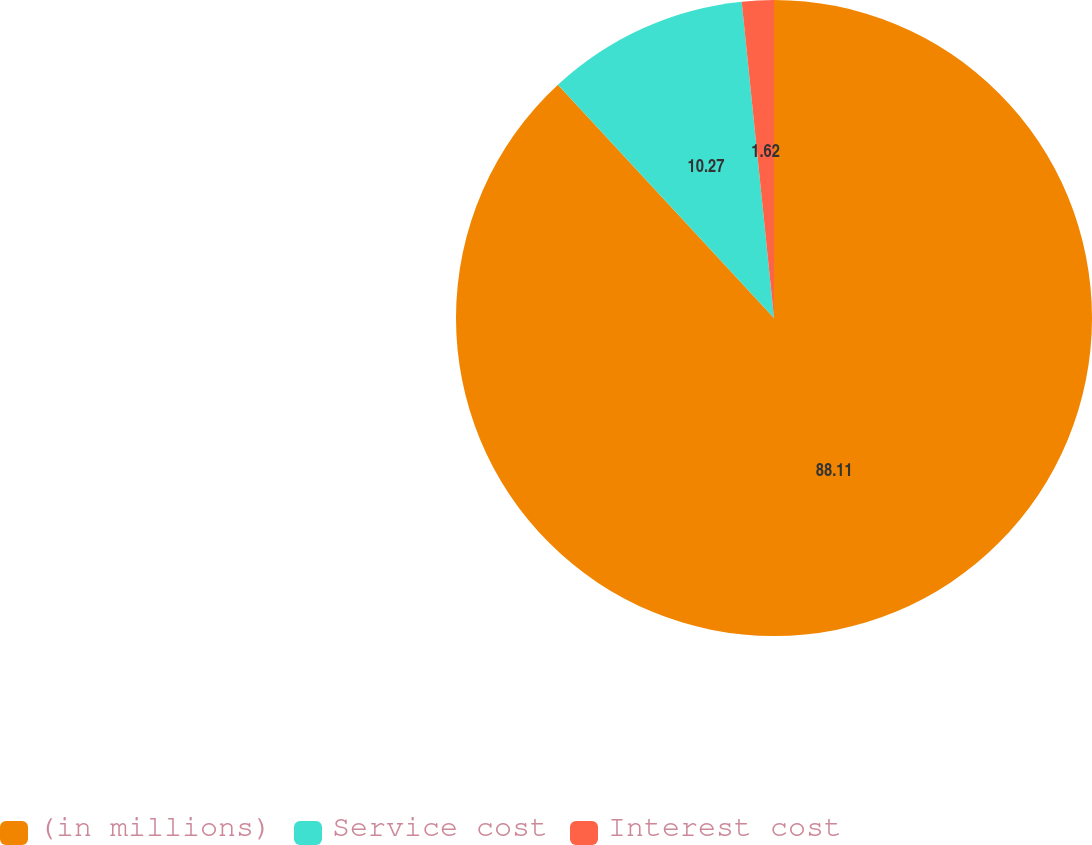Convert chart to OTSL. <chart><loc_0><loc_0><loc_500><loc_500><pie_chart><fcel>(in millions)<fcel>Service cost<fcel>Interest cost<nl><fcel>88.11%<fcel>10.27%<fcel>1.62%<nl></chart> 